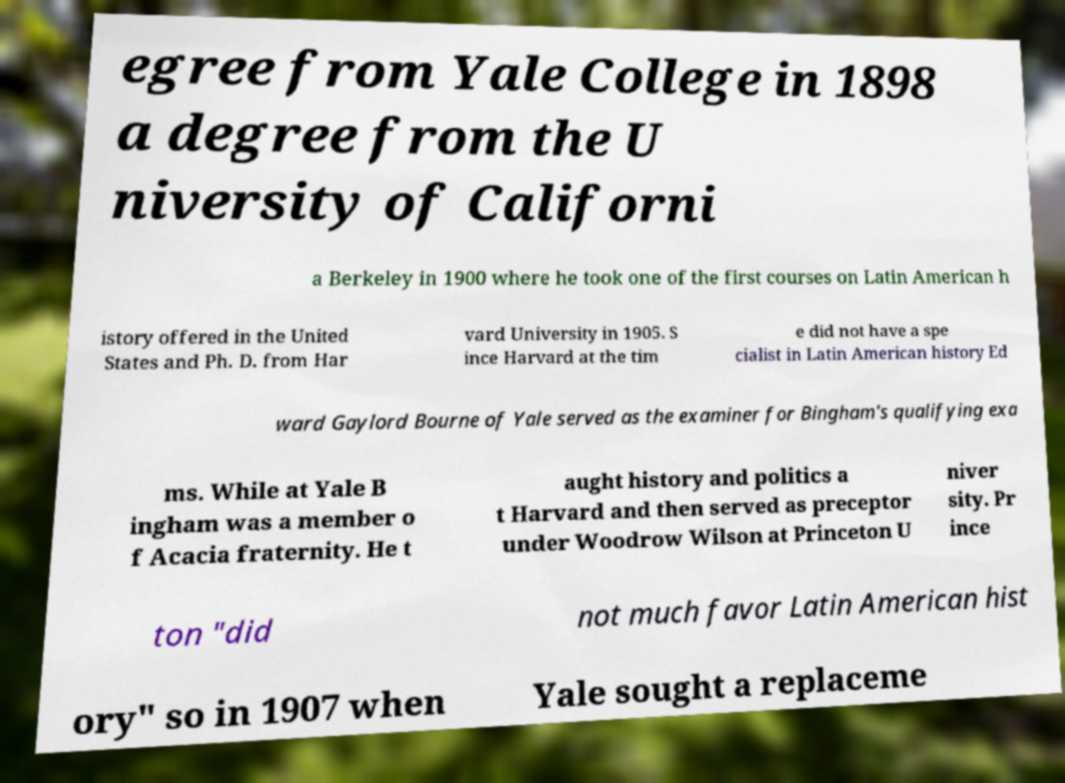Please identify and transcribe the text found in this image. egree from Yale College in 1898 a degree from the U niversity of Californi a Berkeley in 1900 where he took one of the first courses on Latin American h istory offered in the United States and Ph. D. from Har vard University in 1905. S ince Harvard at the tim e did not have a spe cialist in Latin American history Ed ward Gaylord Bourne of Yale served as the examiner for Bingham's qualifying exa ms. While at Yale B ingham was a member o f Acacia fraternity. He t aught history and politics a t Harvard and then served as preceptor under Woodrow Wilson at Princeton U niver sity. Pr ince ton "did not much favor Latin American hist ory" so in 1907 when Yale sought a replaceme 